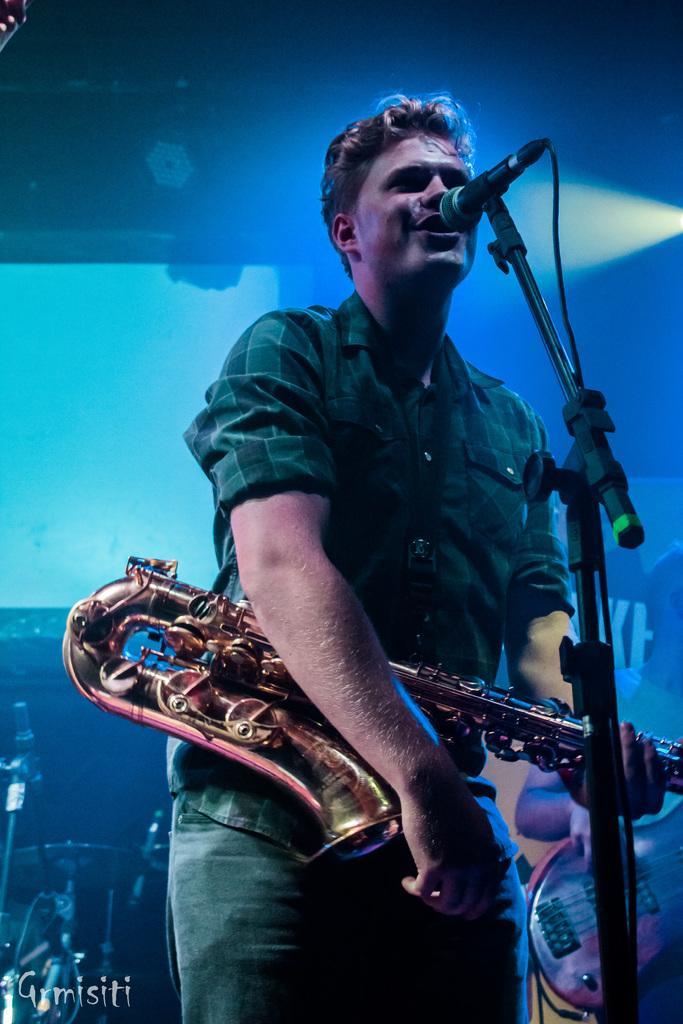In one or two sentences, can you explain what this image depicts? In this picture I can see a man is standing and singing in the microphone. He wore shirt, trouser and also holding a trumpet in his hands. At the bottom there is the watermark. 